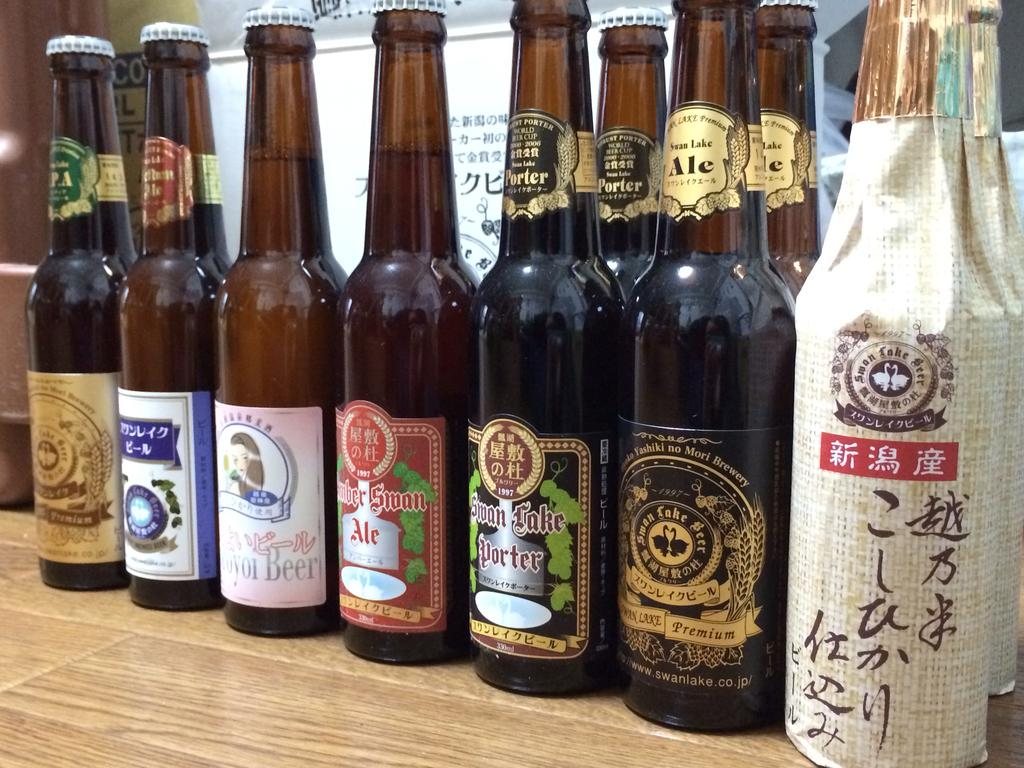<image>
Give a short and clear explanation of the subsequent image. A series of ales and porters sit next to each other. 